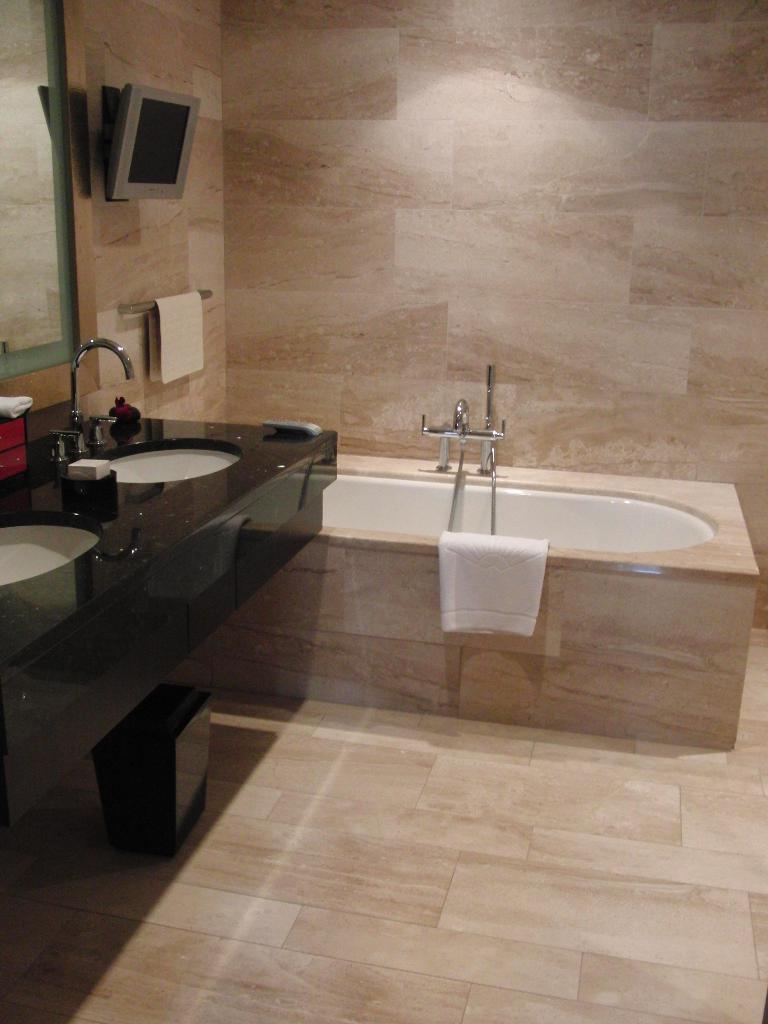How would you summarize this image in a sentence or two? In this picture we can see a bathtub, towel, taps, sinks, handle, monitor, mirror, wall and the floor. 